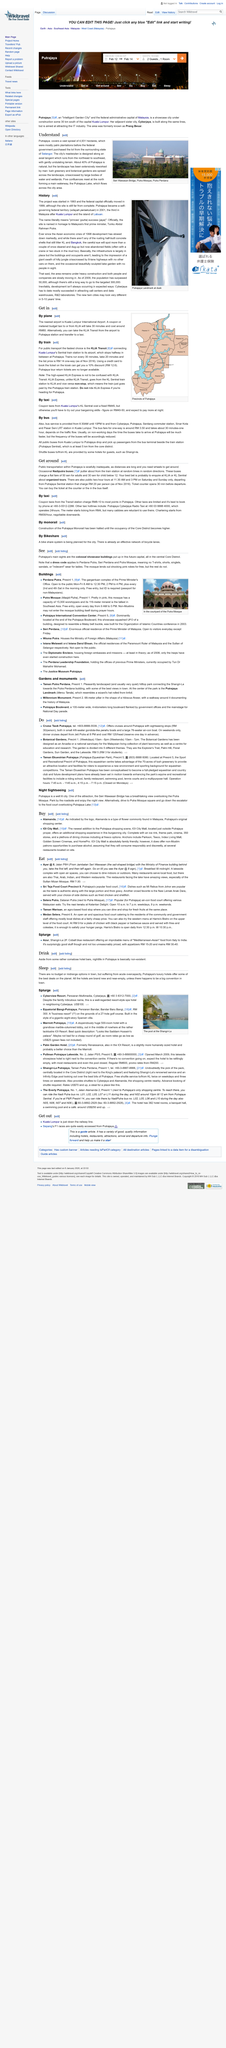Outline some significant characteristics in this image. The Seri Wawasan bridge is depicted in the picture. Putrajaya is approximately 40% neutral. The city's masterplan is designed along an axial tangent that runs from the northeast to southeast, with gently undulating terrain as depicted in the provided image. 